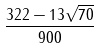<formula> <loc_0><loc_0><loc_500><loc_500>\frac { 3 2 2 - 1 3 \sqrt { 7 0 } } { 9 0 0 }</formula> 